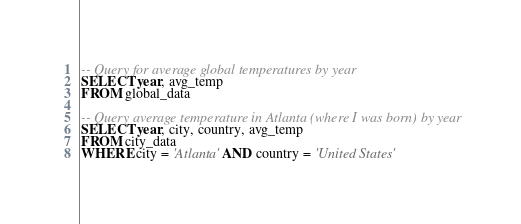Convert code to text. <code><loc_0><loc_0><loc_500><loc_500><_SQL_>-- Query for average global temperatures by year
SELECT year, avg_temp
FROM global_data

-- Query average temperature in Atlanta (where I was born) by year
SELECT year, city, country, avg_temp
FROM city_data
WHERE city = 'Atlanta' AND country = 'United States'
</code> 